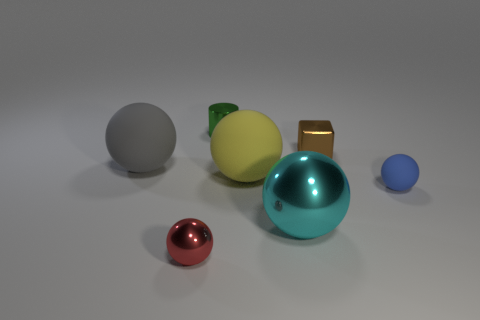Subtract all cyan spheres. How many spheres are left? 4 Subtract all yellow spheres. How many spheres are left? 4 Subtract all cyan spheres. Subtract all brown cylinders. How many spheres are left? 4 Add 2 purple shiny things. How many objects exist? 9 Subtract all cylinders. How many objects are left? 6 Subtract all large cyan matte balls. Subtract all small green objects. How many objects are left? 6 Add 3 big shiny spheres. How many big shiny spheres are left? 4 Add 3 green shiny objects. How many green shiny objects exist? 4 Subtract 0 brown cylinders. How many objects are left? 7 